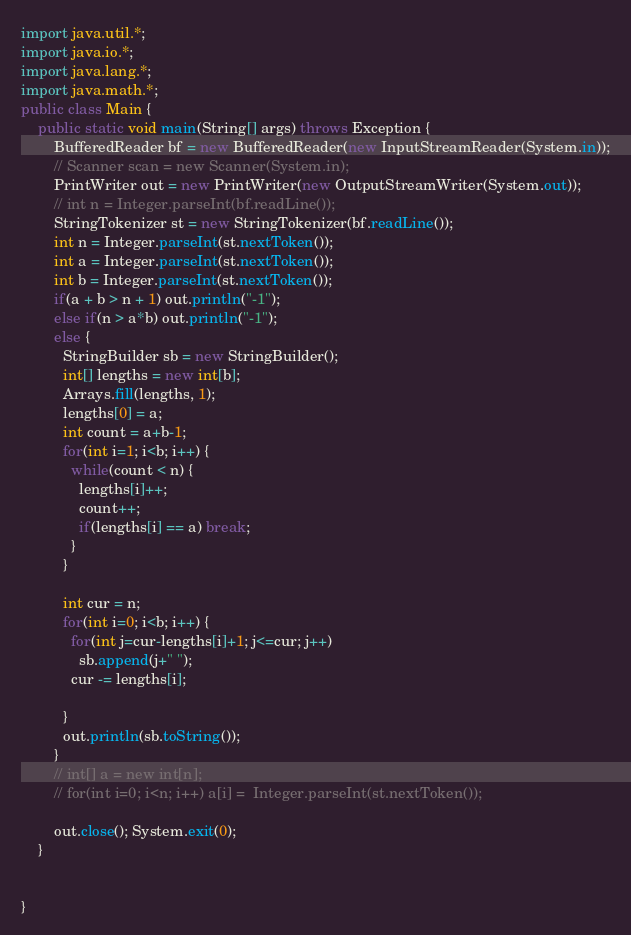<code> <loc_0><loc_0><loc_500><loc_500><_Java_>import java.util.*;
import java.io.*;
import java.lang.*;
import java.math.*;
public class Main {
    public static void main(String[] args) throws Exception {
        BufferedReader bf = new BufferedReader(new InputStreamReader(System.in));
        // Scanner scan = new Scanner(System.in);
        PrintWriter out = new PrintWriter(new OutputStreamWriter(System.out));
        // int n = Integer.parseInt(bf.readLine());
        StringTokenizer st = new StringTokenizer(bf.readLine());
        int n = Integer.parseInt(st.nextToken());
        int a = Integer.parseInt(st.nextToken());
        int b = Integer.parseInt(st.nextToken());
        if(a + b > n + 1) out.println("-1");
        else if(n > a*b) out.println("-1");
        else {
          StringBuilder sb = new StringBuilder();
          int[] lengths = new int[b];
          Arrays.fill(lengths, 1);
          lengths[0] = a;
          int count = a+b-1;
          for(int i=1; i<b; i++) {
            while(count < n) {
              lengths[i]++;
              count++;
              if(lengths[i] == a) break;
            }
          }

          int cur = n;
          for(int i=0; i<b; i++) {
            for(int j=cur-lengths[i]+1; j<=cur; j++)
              sb.append(j+" ");
            cur -= lengths[i];

          }
          out.println(sb.toString());
        }
        // int[] a = new int[n];
        // for(int i=0; i<n; i++) a[i] =  Integer.parseInt(st.nextToken());

        out.close(); System.exit(0);
    }


}
</code> 